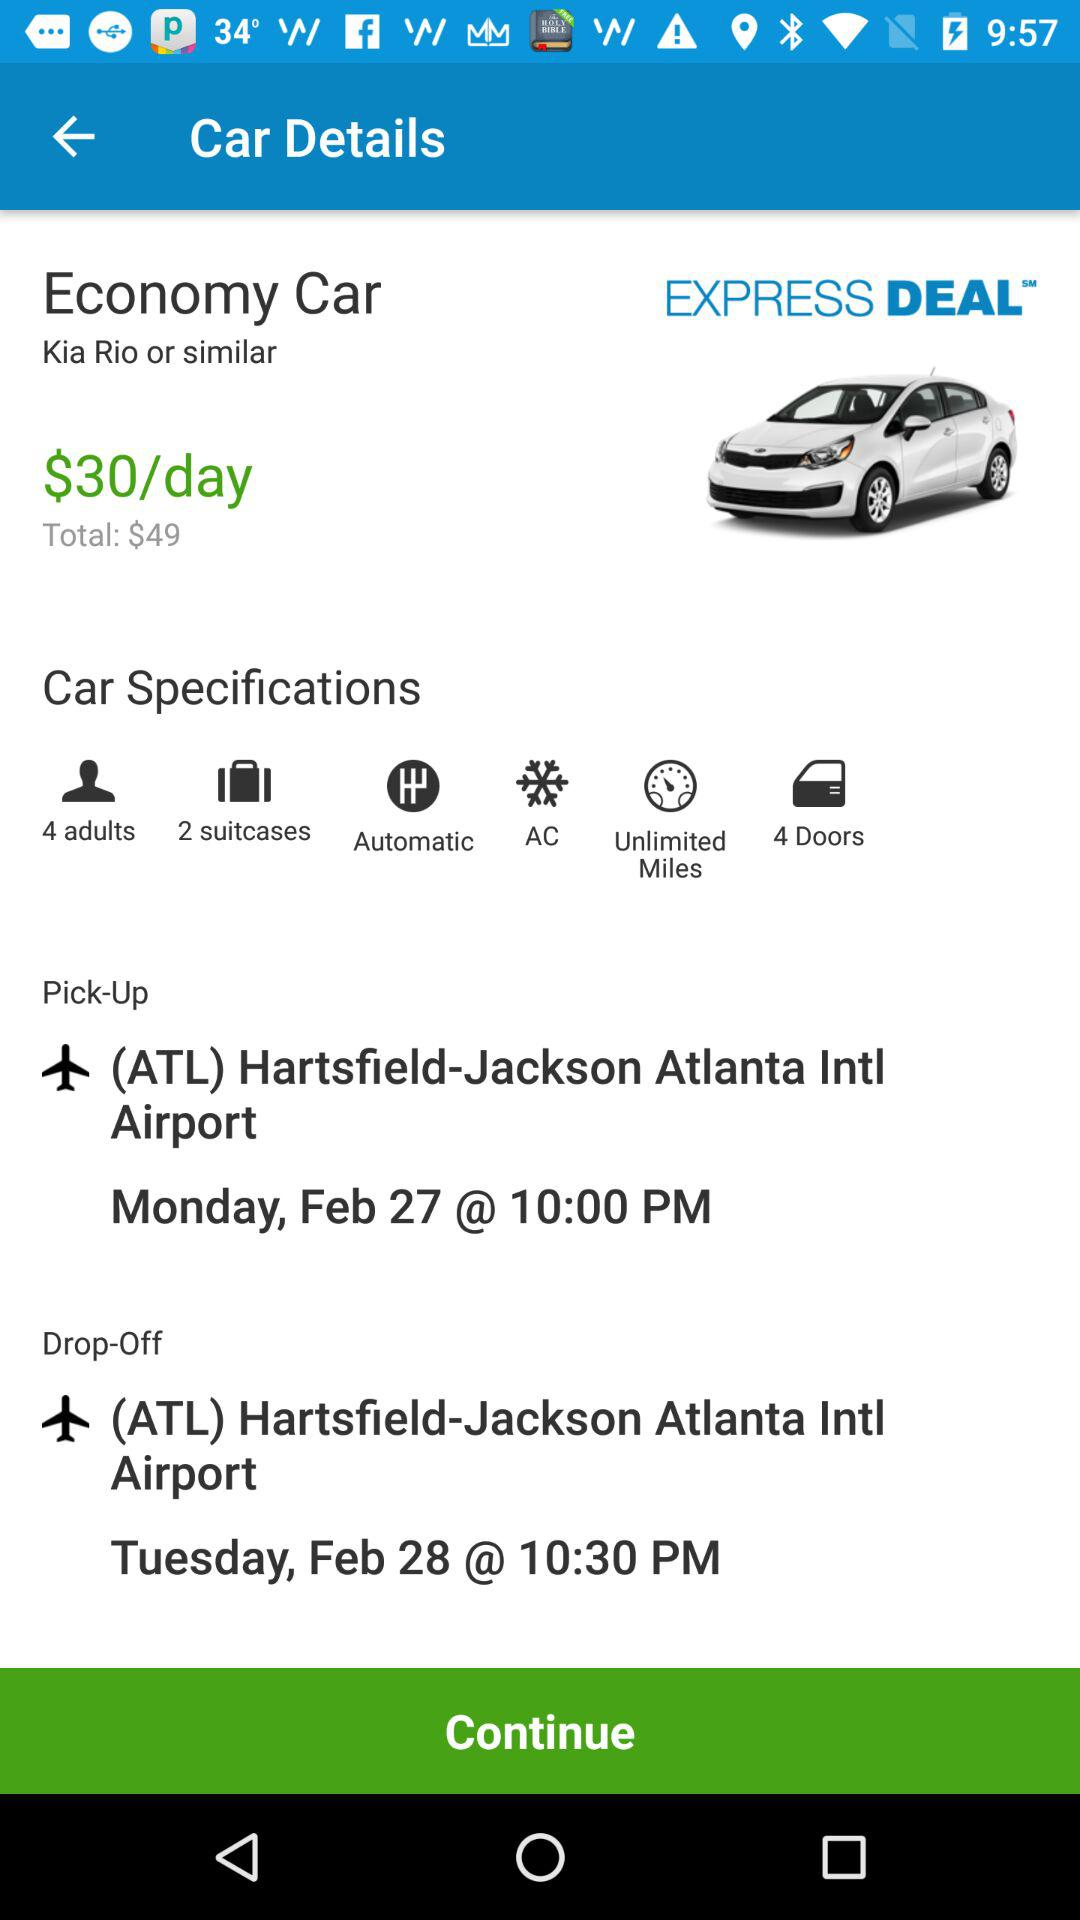What is the airport name? The airport name is (ATL) Hartsfield-Jackson Atlanta Intl Airport. 